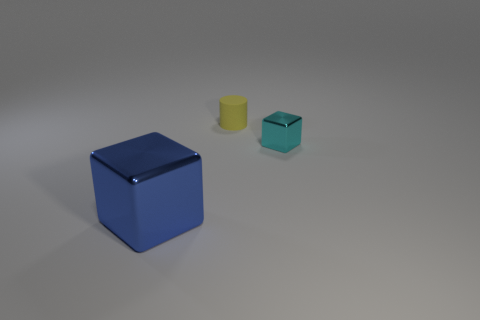Are there any other things that are the same size as the blue cube?
Make the answer very short. No. How many blocks are either shiny objects or blue metallic things?
Make the answer very short. 2. Is there a small cyan metallic block behind the shiny block to the left of the cyan object?
Make the answer very short. Yes. Are there fewer big shiny blocks than small blue balls?
Give a very brief answer. No. How many other metallic objects have the same shape as the big shiny thing?
Your answer should be very brief. 1. How many brown objects are either big metallic cubes or metal objects?
Keep it short and to the point. 0. There is a thing that is behind the metal object that is to the right of the yellow rubber cylinder; how big is it?
Make the answer very short. Small. There is another object that is the same shape as the small shiny object; what is its material?
Offer a terse response. Metal. What number of other objects have the same size as the cyan thing?
Offer a terse response. 1. Is the yellow matte thing the same size as the blue thing?
Give a very brief answer. No. 